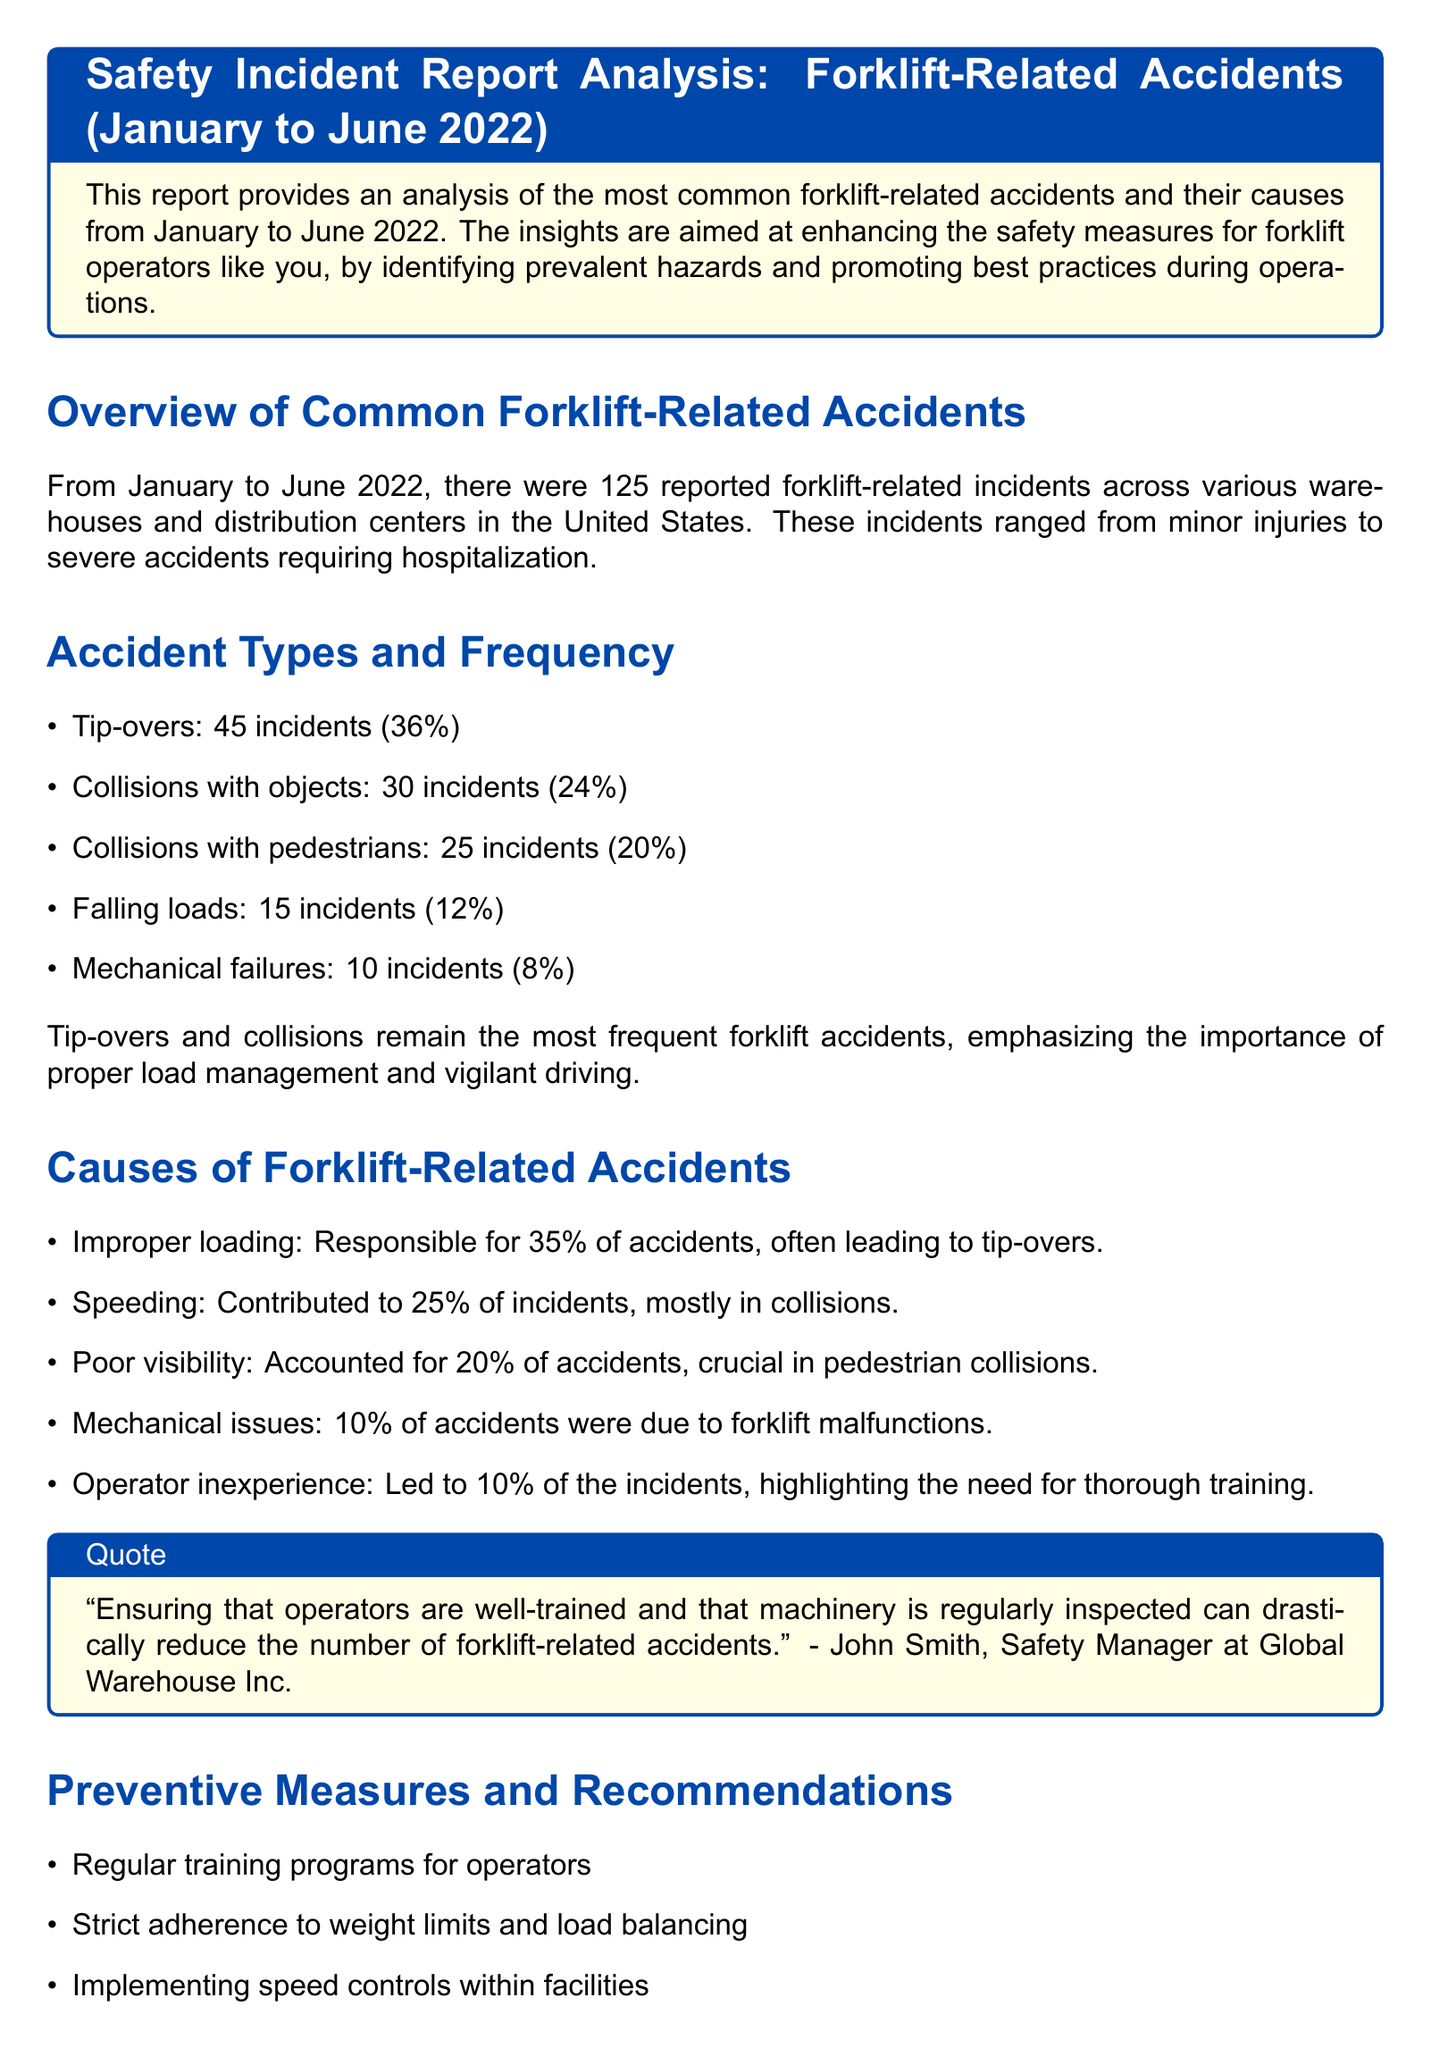What is the total number of reported forklift-related incidents? The total number of reported incidents is clearly stated to be 125 in the document.
Answer: 125 What percentage of accidents were due to tip-overs? The document lists tip-overs as responsible for 36% of the incidents.
Answer: 36% Which accident type had the second highest frequency? Referring to the list of accident types, collisions with objects rank second, with 30 incidents.
Answer: Collisions with objects What is the main cause of accidents according to the document? Improper loading is identified as responsible for 35% of accidents, making it the main cause.
Answer: Improper loading What preventive measure is recommended to reduce forklift accidents? Regular training programs for operators are highlighted as a key preventive measure in the recommendations.
Answer: Regular training programs How many incidents were caused by mechanical failures? The report states that mechanical failures accounted for 10 incidents.
Answer: 10 incidents What percentage of accidents was due to operator inexperience? The document indicates that operator inexperience led to 10% of incidents.
Answer: 10% Who provided a quote about training and safety protocols? The quote about training and safety protocols is attributed to Emily Turner, Operations Supervisor at LogisticsPro.
Answer: Emily Turner 